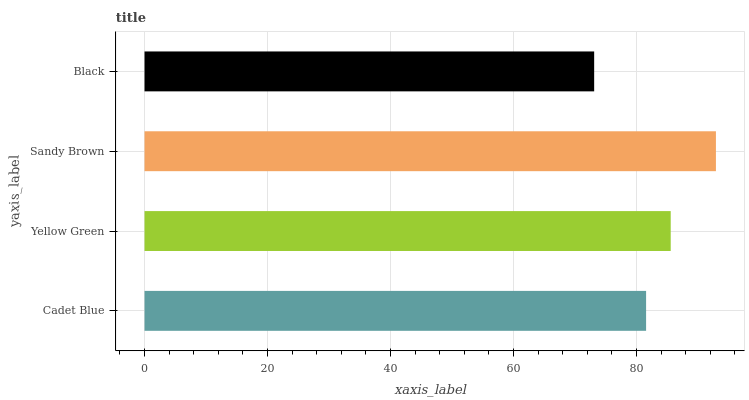Is Black the minimum?
Answer yes or no. Yes. Is Sandy Brown the maximum?
Answer yes or no. Yes. Is Yellow Green the minimum?
Answer yes or no. No. Is Yellow Green the maximum?
Answer yes or no. No. Is Yellow Green greater than Cadet Blue?
Answer yes or no. Yes. Is Cadet Blue less than Yellow Green?
Answer yes or no. Yes. Is Cadet Blue greater than Yellow Green?
Answer yes or no. No. Is Yellow Green less than Cadet Blue?
Answer yes or no. No. Is Yellow Green the high median?
Answer yes or no. Yes. Is Cadet Blue the low median?
Answer yes or no. Yes. Is Sandy Brown the high median?
Answer yes or no. No. Is Yellow Green the low median?
Answer yes or no. No. 